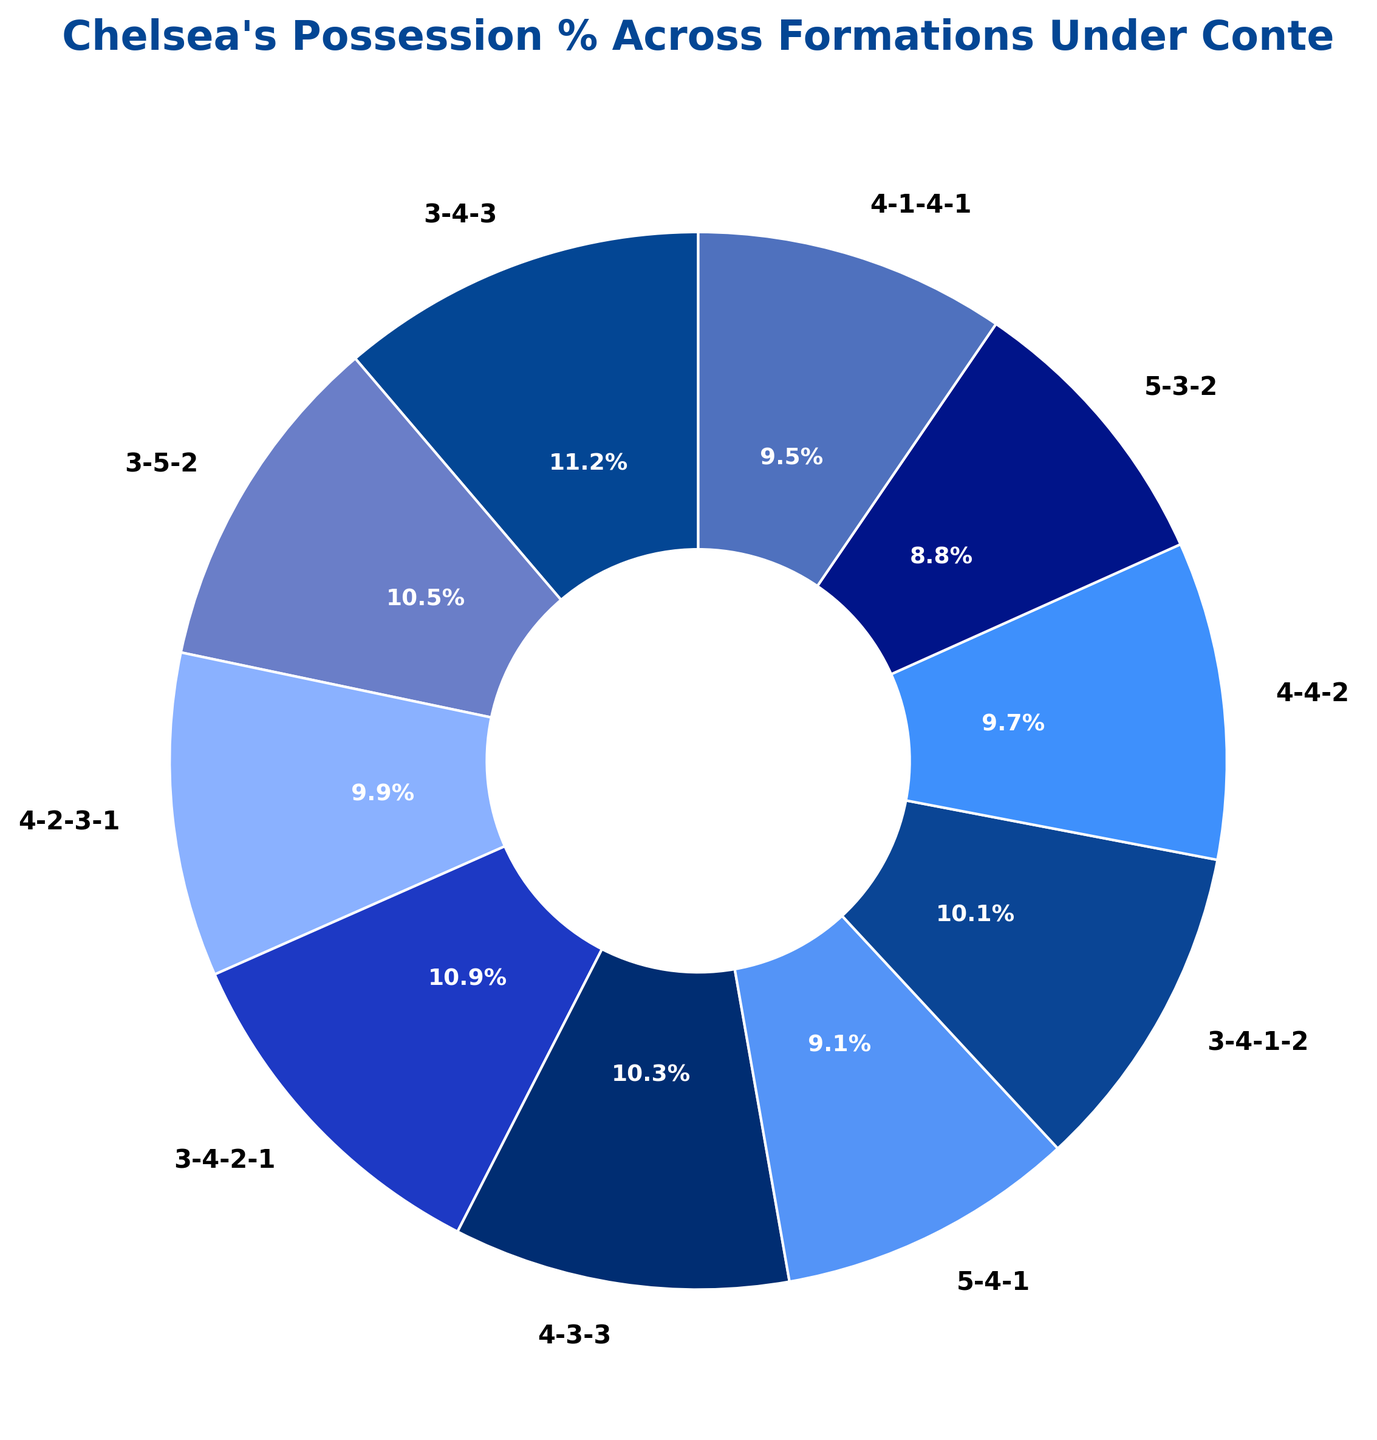What is the formation with the highest possession percentage? The formation with the highest possession percentage can be found by identifying the segment with the largest percentage. The 3-4-3 formation shows the highest percentage.
Answer: 3-4-3 Which formation has the lowest possession percentage? The formation with the lowest percentage can be found by identifying the segment with the smallest percentage. The 5-3-2 formation shows the lowest percentage.
Answer: 5-3-2 Comparing 4-2-3-1 to 4-4-2, which formation has a higher possession percentage? To compare the two formations, look for their respective percentages in the pie chart. The 4-2-3-1 formation has a possession percentage of 52%, while the 4-4-2 formation stands at 51%.
Answer: 4-2-3-1 What is the total possession percentage for all formations ending in '1'? Sum the percentages of formations ending in '1': (3-4-2-1) 57% + (4-2-3-1) 52% + (4-1-4-1) 50% = 159%.
Answer: 159% Which segment has a color similar to dark blue? Identify the segment based on its color. The 4-2-3-1 formation, represented with a color similar to dark blue, has a possession percentage of 52%.
Answer: 4-2-3-1 How much higher is the possession percentage of 3-4-3 compared to 5-3-2? Subtract the percentage of 5-3-2 from the percentage of 3-4-3: 59% - 46% = 13%.
Answer: 13% What is the average possession percentage across all formations? Sum all percentages and divide by the total number of formations: (59 + 55 + 52 + 57 + 54 + 48 + 53 + 51 + 46 + 50) / 10 = 52.5%.
Answer: 52.5% Is the possession percentage for any 5-back formation higher than 50%? The 5-back formations (5-4-1 and 5-3-2) have possession percentages of 48% and 46%, respectively, both of which are below 50%.
Answer: No Does the 3-4-3 formation have more possession than the 4-3-3 formation? Compare the possession percentages: 3-4-3 has 59%, and 4-3-3 has 54%.
Answer: Yes 